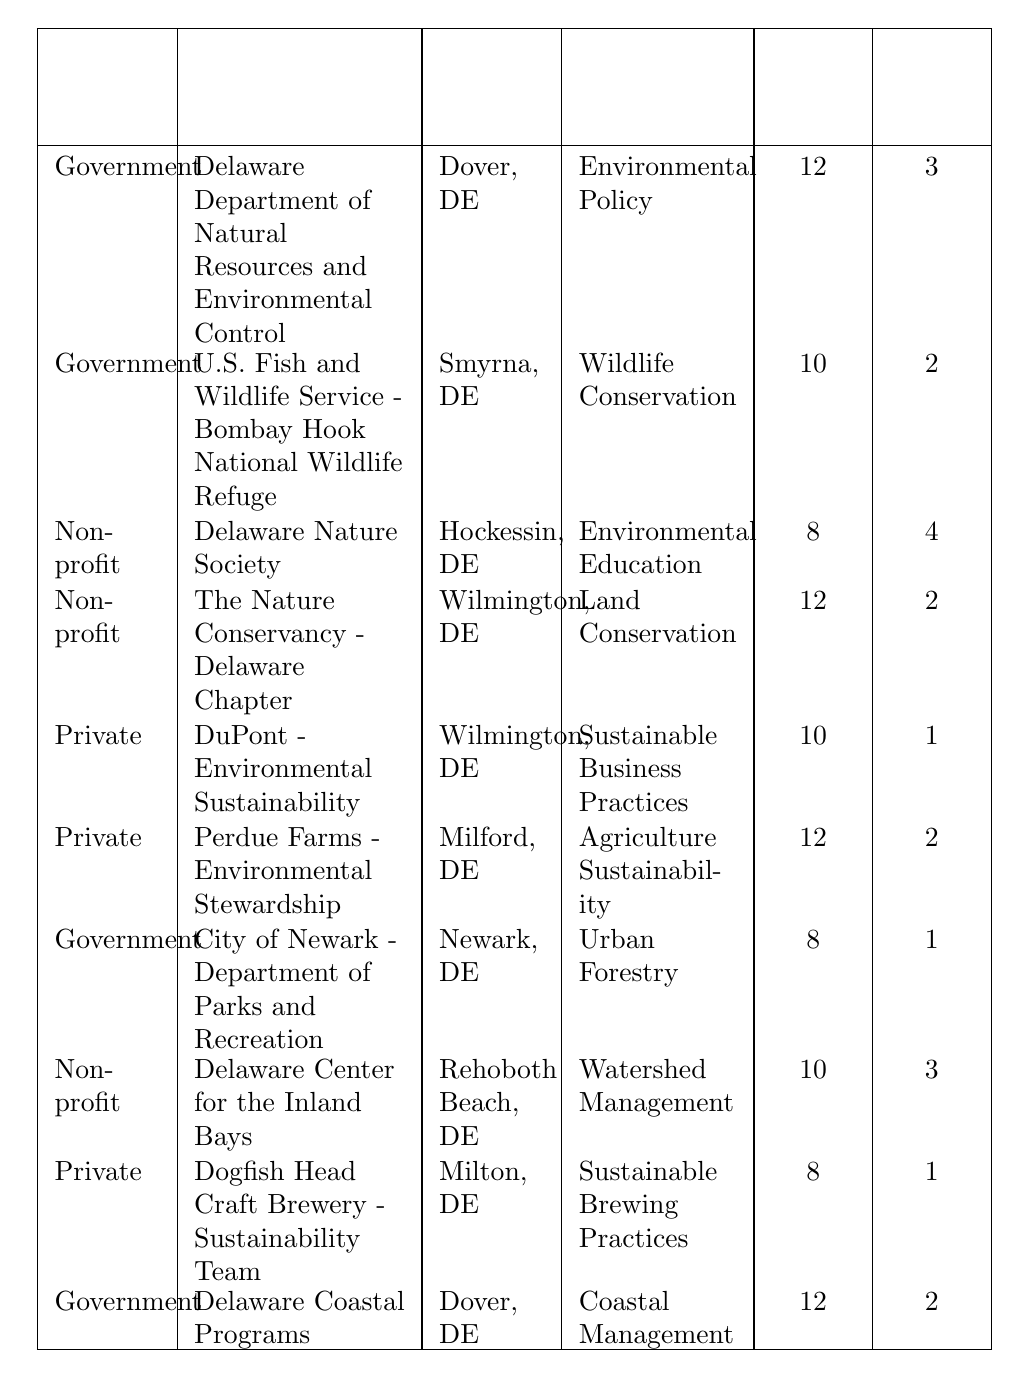What are the total internship positions available in the private sector? Looking at the table, the private sector internships listed are "DuPont - Environmental Sustainability" (1 position), "Perdue Farms - Environmental Stewardship" (2 positions), and "Dogfish Head Craft Brewery - Sustainability Team" (1 position). Adding these up: 1 + 2 + 1 = 4 positions available in the private sector.
Answer: 4 Which organization offers the longest internship duration? The table lists the durations of the internships. The Delaware Department of Natural Resources and Environmental Control offers an internship for 12 weeks and is the longest along with others such as Perdue Farms and The Nature Conservancy - Delaware Chapter (both also 12 weeks). However, since the question asks for organizations, the answer will be the Delaware Department of Natural Resources and Environmental Control.
Answer: Delaware Department of Natural Resources and Environmental Control Is there any organization that offers an internship in "Wildlife Conservation"? Yes, the "U.S. Fish and Wildlife Service - Bombay Hook National Wildlife Refuge" offers an internship in Wildlife Conservation according to the table.
Answer: Yes What is the average duration of internships offered by non-profit organizations? The non-profit organizations listed are the Delaware Nature Society (8 weeks), The Nature Conservancy (12 weeks), and the Delaware Center for the Inland Bays (10 weeks). To find the average, sum the durations: 8 + 12 + 10 = 30 weeks. Then divide by the number of organizations: 30/3 = 10 weeks.
Answer: 10 weeks Which sector has the highest number of internship positions available? The sectors listed are Government, Non-profit, and Private. By counting the positions: Government (6 positions), Non-profit (9 positions), Private (4 positions). The Non-profit sector has the highest number with 9 positions available.
Answer: Non-profit How many weeks do government internships last on average? The government internships listed are for 12 weeks (3 positions), 10 weeks (2 positions), and 8 weeks (1 position). The total duration is (12*3 + 10*2 + 8*1) = 36 + 20 + 8 = 64 weeks for 6 positions. Thus, the average duration is 64/6 ≈ 10.67 weeks.
Answer: Approximately 10.67 weeks Is "Urban Forestry" an internship type offered by a private organization? A review of the table indicates that "Urban Forestry" is offered by the City of Newark, which is a government organization, not a private one. Therefore, it is not offered by a private organization.
Answer: No Which organization has the highest number of positions available, and how many are there? The organization "Delaware Nature Society" offers the highest number of internship positions with a total of 4 positions according to the table.
Answer: Delaware Nature Society, 4 positions How many more weeks is the internship in "Delaware Department of Natural Resources and Environmental Control" compared to "City of Newark - Department of Parks and Recreation"? The internship in the Delaware Department of Natural Resources is 12 weeks long while the City of Newark's internship is 8 weeks long. The difference is 12 - 8 = 4 weeks.
Answer: 4 weeks What percentage of the total internship positions available come from the Government sector? Government organizations have 3 + 2 + 1 + 2 = 8 positions. The total positions across all sectors are 3 + 2 + 4 + 2 + 1 + 2 + 1 + 3 + 1 + 2 = 21 positions total. Thus, the percentage from the Government sector is (8/21) * 100 ≈ 38.1%.
Answer: Approximately 38.1% 